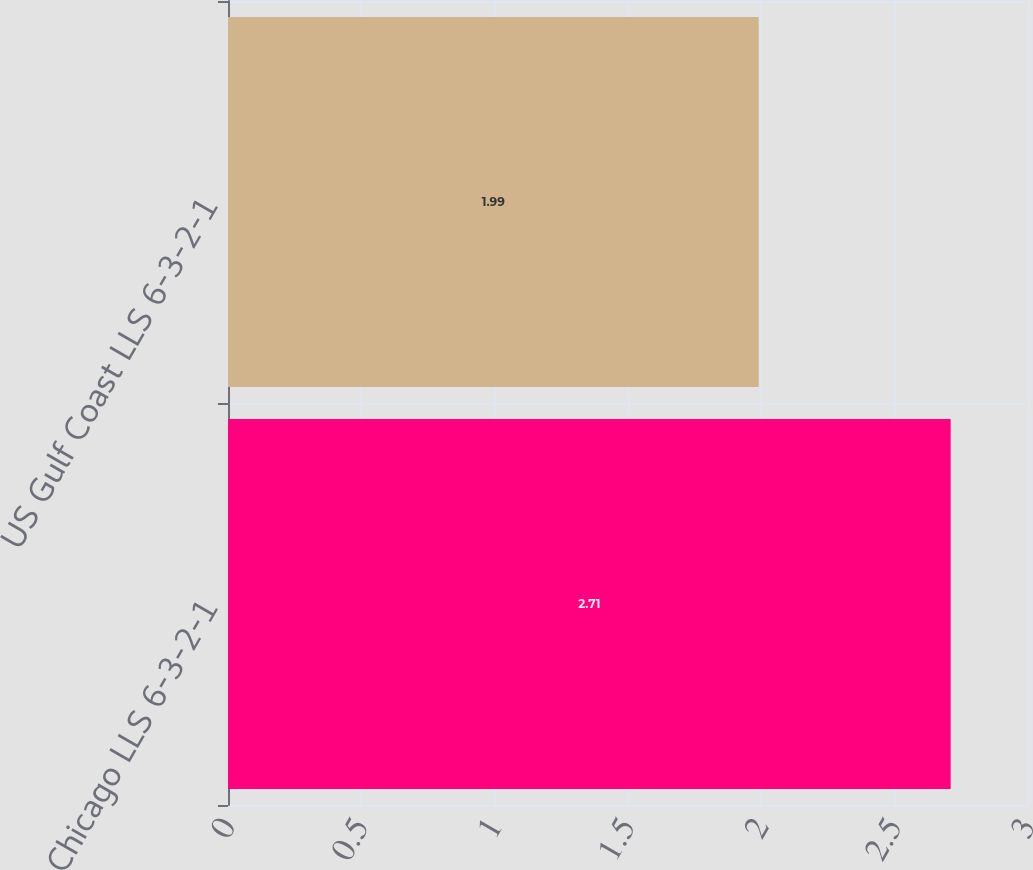Convert chart to OTSL. <chart><loc_0><loc_0><loc_500><loc_500><bar_chart><fcel>Chicago LLS 6-3-2-1<fcel>US Gulf Coast LLS 6-3-2-1<nl><fcel>2.71<fcel>1.99<nl></chart> 